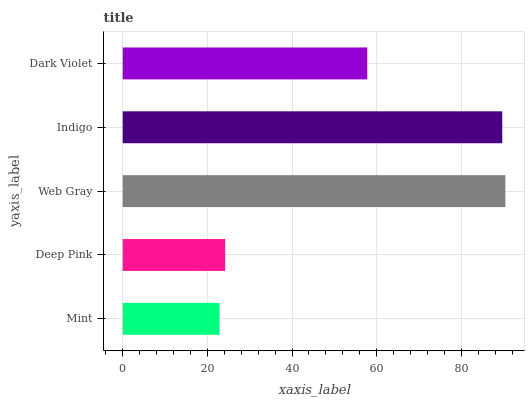Is Mint the minimum?
Answer yes or no. Yes. Is Web Gray the maximum?
Answer yes or no. Yes. Is Deep Pink the minimum?
Answer yes or no. No. Is Deep Pink the maximum?
Answer yes or no. No. Is Deep Pink greater than Mint?
Answer yes or no. Yes. Is Mint less than Deep Pink?
Answer yes or no. Yes. Is Mint greater than Deep Pink?
Answer yes or no. No. Is Deep Pink less than Mint?
Answer yes or no. No. Is Dark Violet the high median?
Answer yes or no. Yes. Is Dark Violet the low median?
Answer yes or no. Yes. Is Indigo the high median?
Answer yes or no. No. Is Mint the low median?
Answer yes or no. No. 